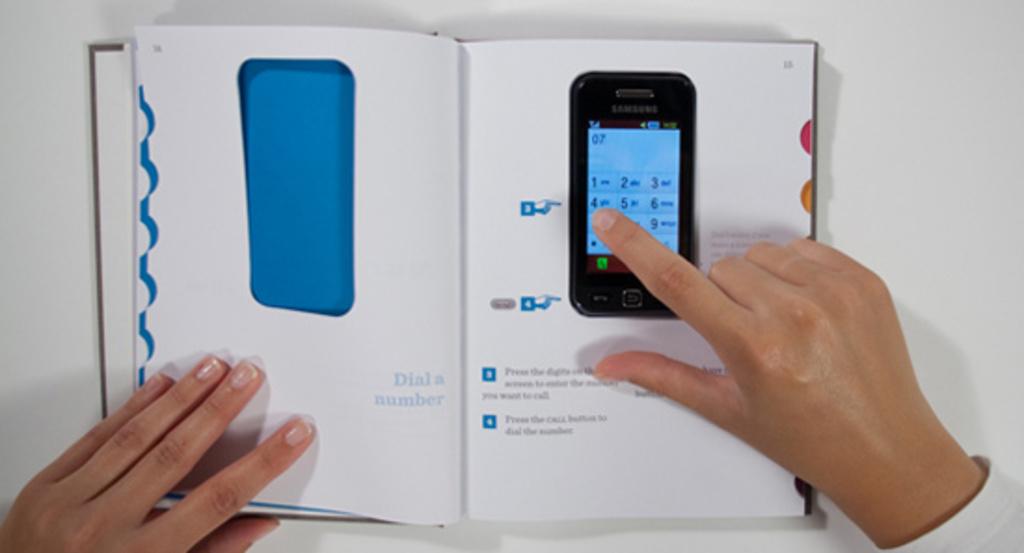What number is the finger pressing?
Your answer should be compact. 7. 